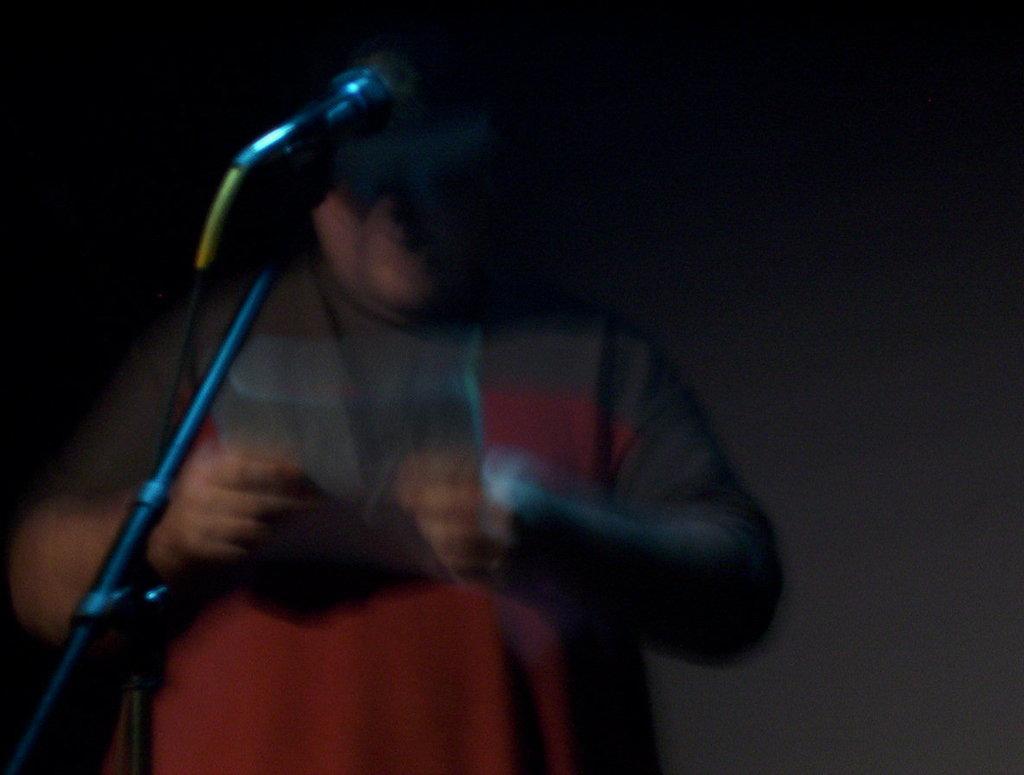Please provide a concise description of this image. In this image I can see a person and a stick and the background is dark. 